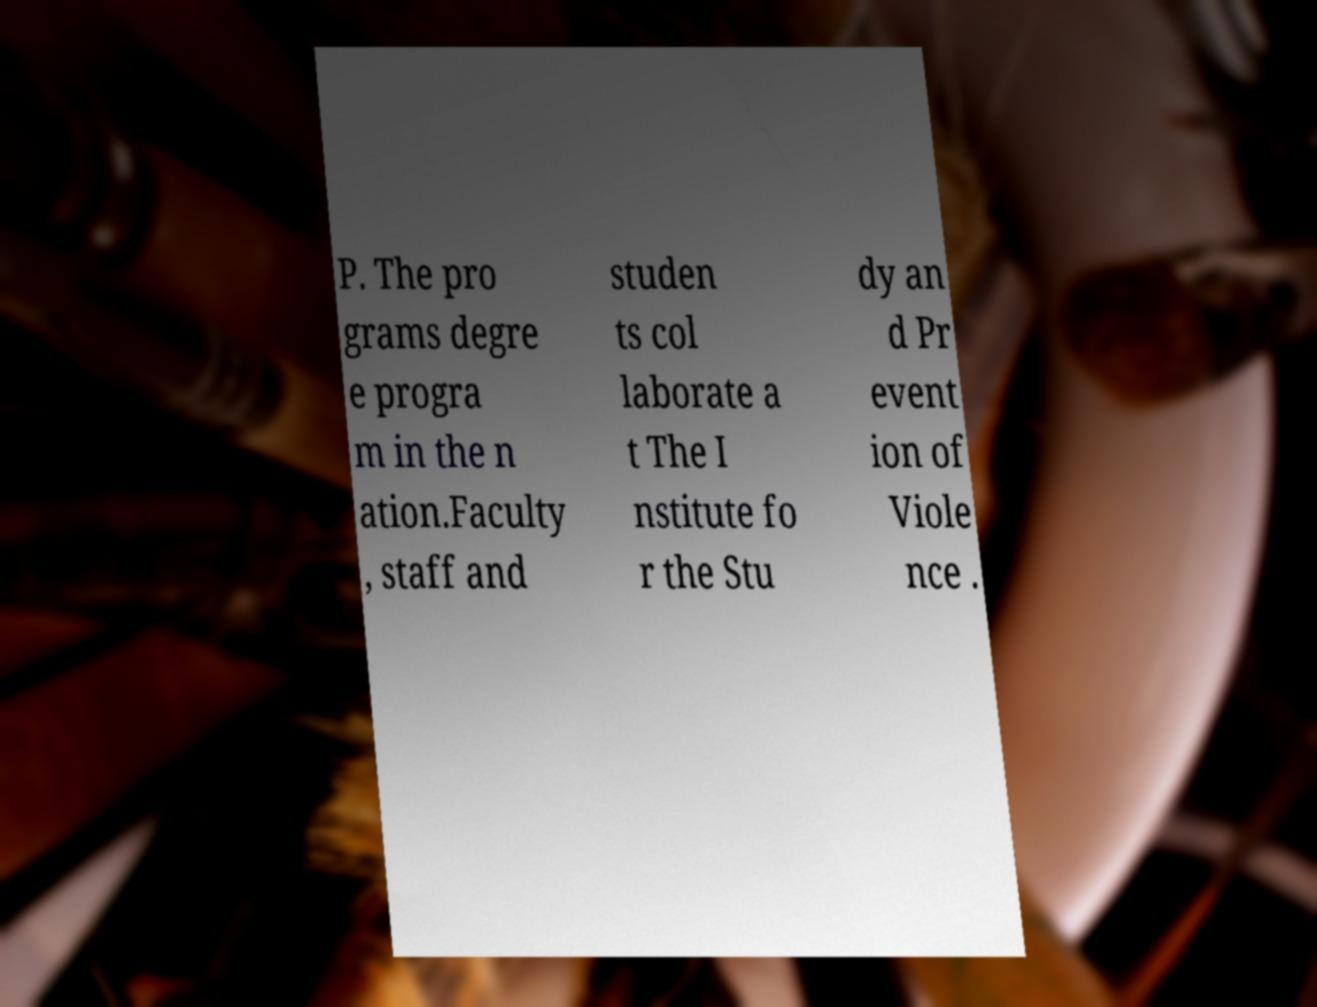Please read and relay the text visible in this image. What does it say? P. The pro grams degre e progra m in the n ation.Faculty , staff and studen ts col laborate a t The I nstitute fo r the Stu dy an d Pr event ion of Viole nce . 